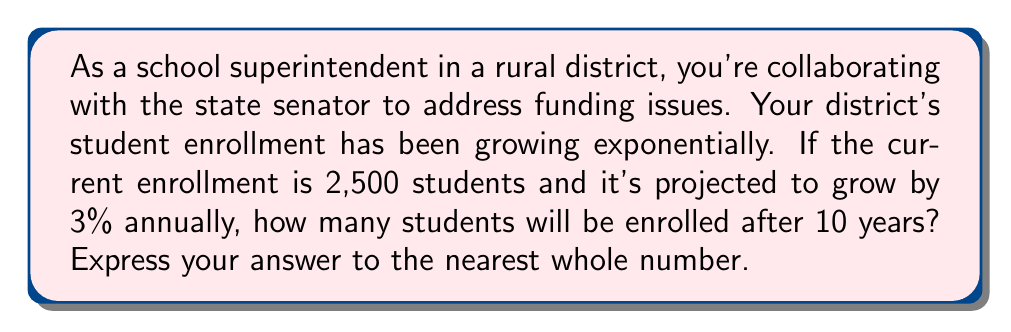Help me with this question. Let's approach this step-by-step using an exponential function:

1) The general form of an exponential growth function is:
   
   $$ A(t) = A_0 \cdot (1 + r)^t $$

   Where:
   $A(t)$ is the amount after time $t$
   $A_0$ is the initial amount
   $r$ is the growth rate (as a decimal)
   $t$ is the time period

2) In this case:
   $A_0 = 2,500$ (initial enrollment)
   $r = 0.03$ (3% annual growth rate)
   $t = 10$ years

3) Plugging these values into our equation:

   $$ A(10) = 2,500 \cdot (1 + 0.03)^{10} $$

4) Let's calculate this:
   
   $$ A(10) = 2,500 \cdot (1.03)^{10} $$
   $$ A(10) = 2,500 \cdot 1.3439 $$
   $$ A(10) = 3,359.75 $$

5) Rounding to the nearest whole number:

   $$ A(10) \approx 3,360 $$
Answer: 3,360 students 